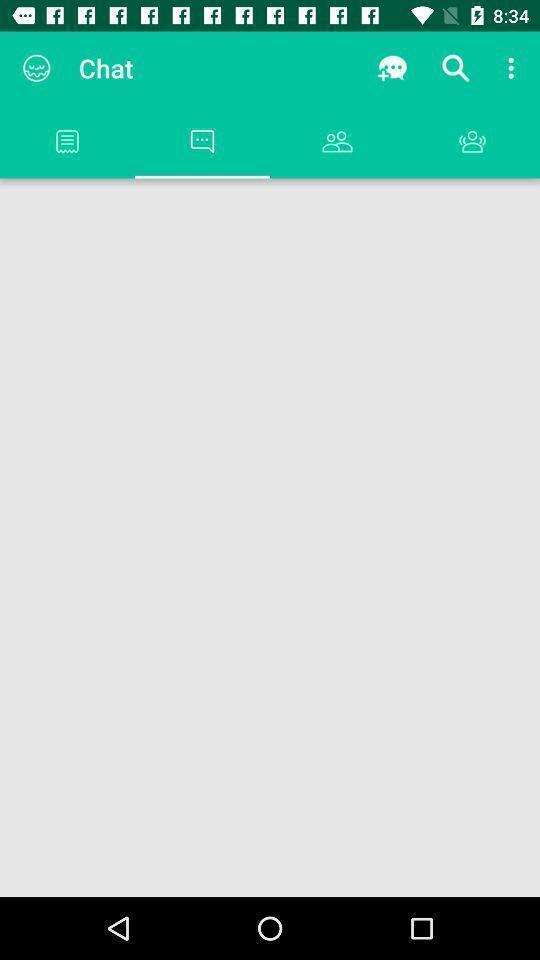Describe this image in words. Display page showing different chat options with multiple icons. 